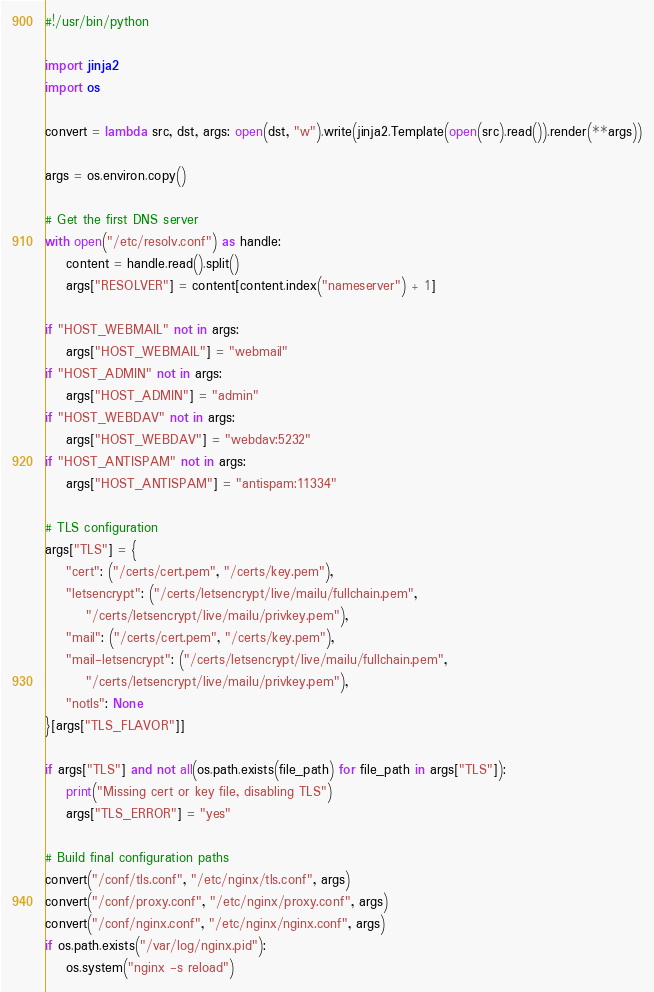Convert code to text. <code><loc_0><loc_0><loc_500><loc_500><_Python_>#!/usr/bin/python

import jinja2
import os

convert = lambda src, dst, args: open(dst, "w").write(jinja2.Template(open(src).read()).render(**args))

args = os.environ.copy()

# Get the first DNS server
with open("/etc/resolv.conf") as handle:
    content = handle.read().split()
    args["RESOLVER"] = content[content.index("nameserver") + 1]

if "HOST_WEBMAIL" not in args:
    args["HOST_WEBMAIL"] = "webmail"
if "HOST_ADMIN" not in args:
    args["HOST_ADMIN"] = "admin"
if "HOST_WEBDAV" not in args:
    args["HOST_WEBDAV"] = "webdav:5232"
if "HOST_ANTISPAM" not in args:
    args["HOST_ANTISPAM"] = "antispam:11334"

# TLS configuration
args["TLS"] = {
    "cert": ("/certs/cert.pem", "/certs/key.pem"),
    "letsencrypt": ("/certs/letsencrypt/live/mailu/fullchain.pem",
        "/certs/letsencrypt/live/mailu/privkey.pem"),
    "mail": ("/certs/cert.pem", "/certs/key.pem"),
    "mail-letsencrypt": ("/certs/letsencrypt/live/mailu/fullchain.pem",
        "/certs/letsencrypt/live/mailu/privkey.pem"),
    "notls": None
}[args["TLS_FLAVOR"]]

if args["TLS"] and not all(os.path.exists(file_path) for file_path in args["TLS"]):
    print("Missing cert or key file, disabling TLS")
    args["TLS_ERROR"] = "yes"

# Build final configuration paths
convert("/conf/tls.conf", "/etc/nginx/tls.conf", args)
convert("/conf/proxy.conf", "/etc/nginx/proxy.conf", args)
convert("/conf/nginx.conf", "/etc/nginx/nginx.conf", args)
if os.path.exists("/var/log/nginx.pid"):
    os.system("nginx -s reload")
</code> 